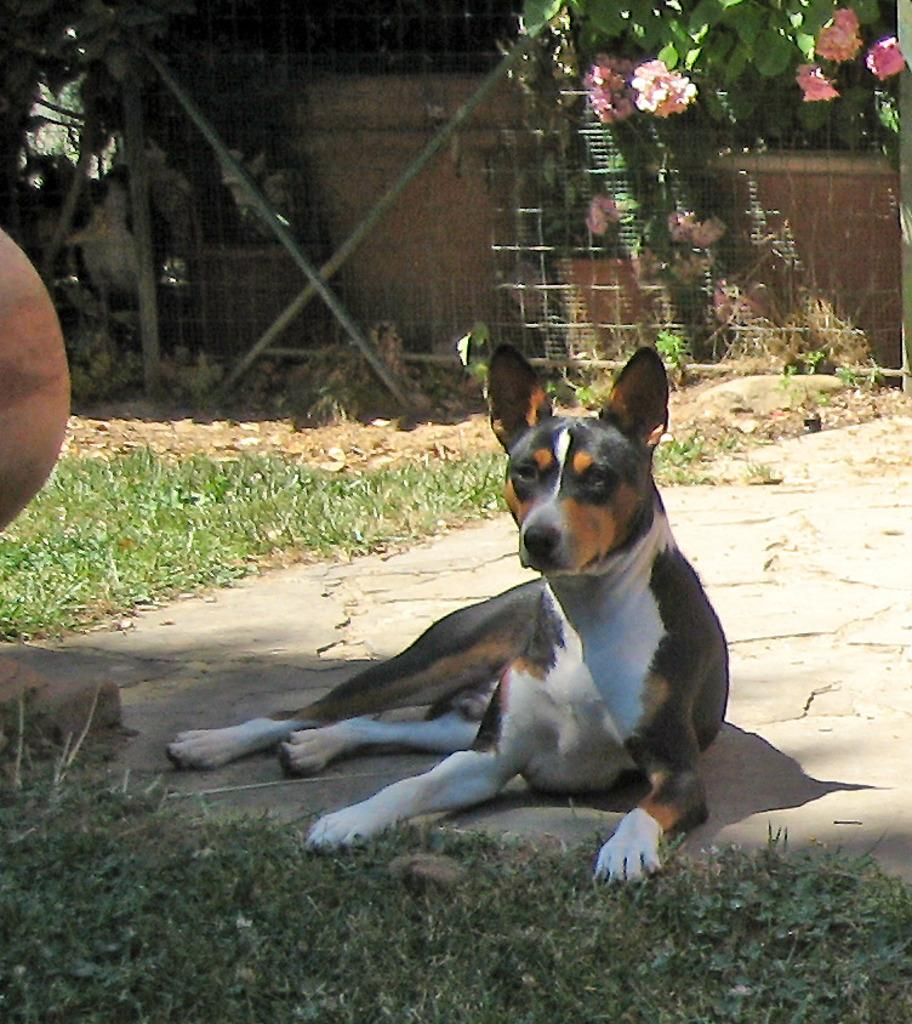What animal can be seen in the image? There is a dog in the image. What is the dog doing in the image? The dog is laying on the ground. What type of surface is the dog laying on? There is grass in the image. What can be seen in the background of the image? There are plants, flowers, rods, and a mesh in the background of the image. Can you see a monkey kissing the dog in the image? No, there is no monkey or any kissing activity depicted in the image. 